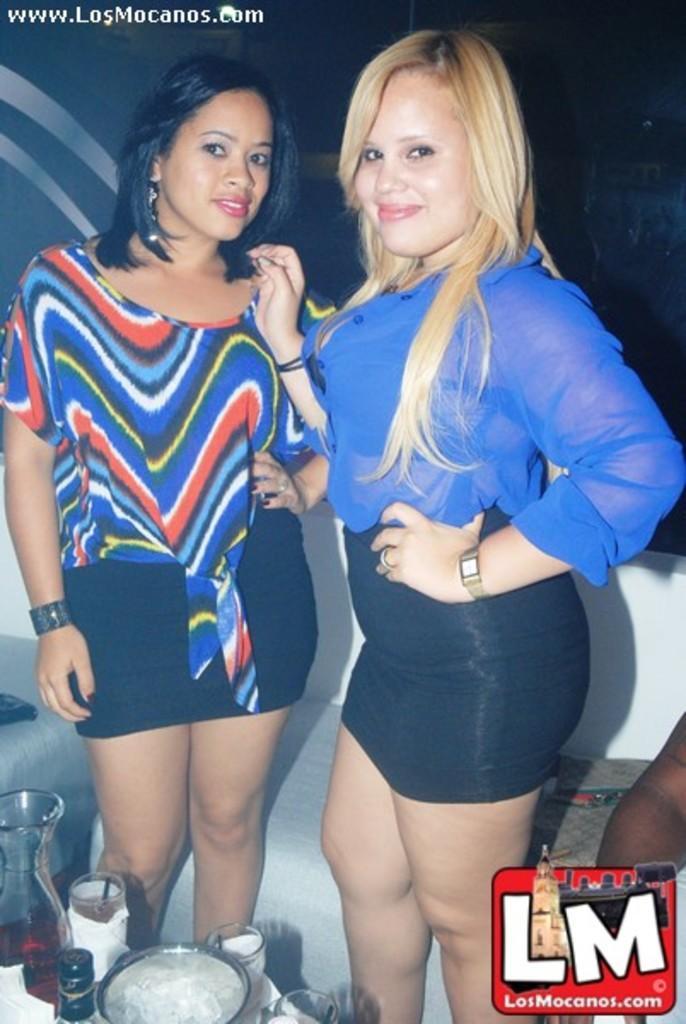Can you describe this image briefly? In this image I see 2 women and I see number of things over here and I see the watermark over here. In the background I see the couch and I see that it is a bit dark over here and I see the watermark over here too and I see that both of them are smiling. 